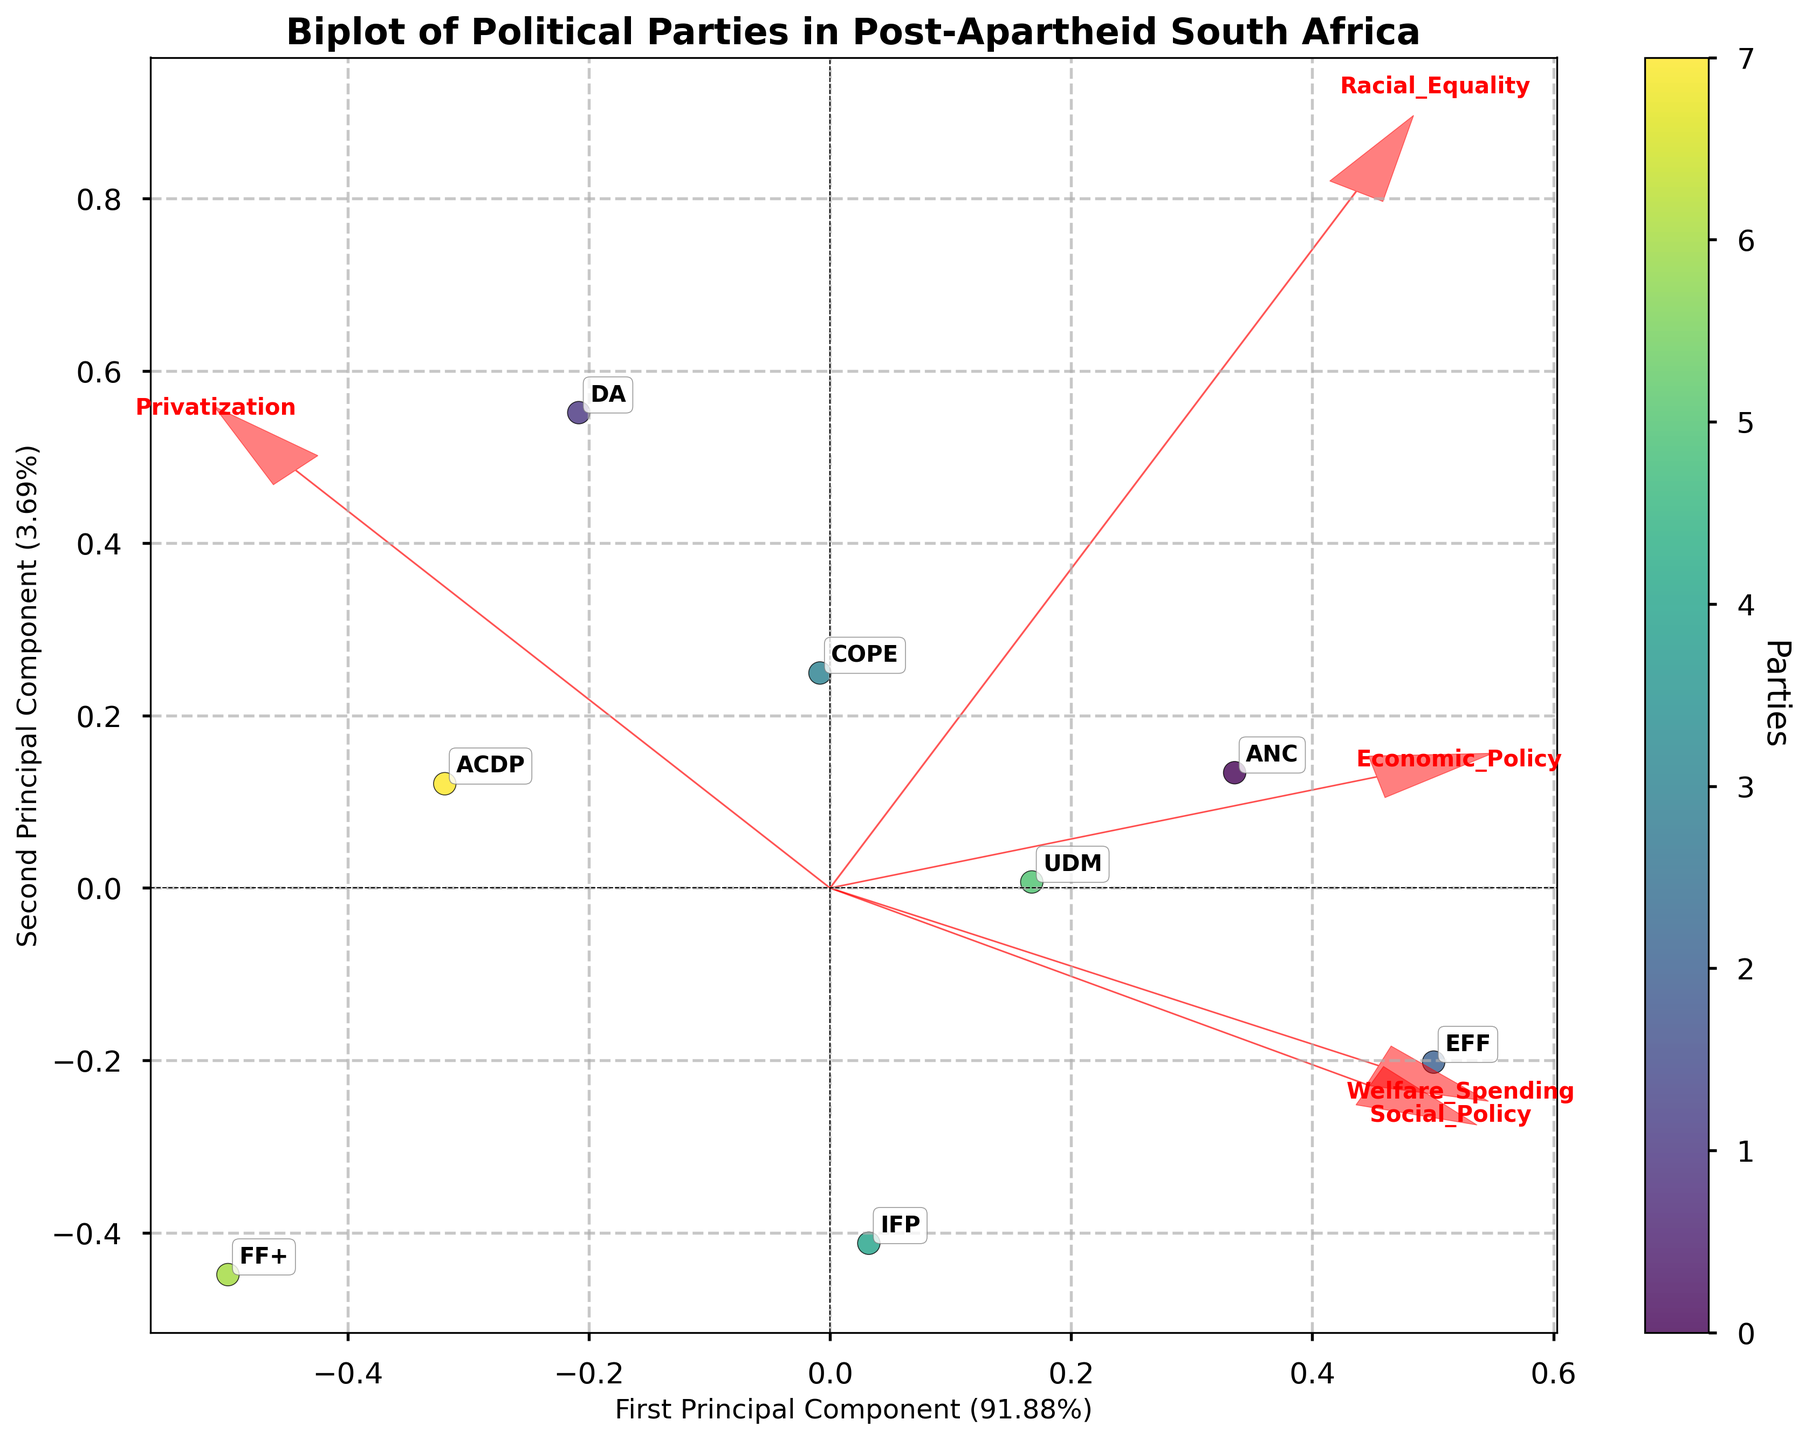What are the titles of the axes? The x-axis represents the "First Principal Component" while the y-axis represents the "Second Principal Component." Both components are derived from the PCA analysis and the variance ratio is also indicated on each axis.
Answer: "First Principal Component" and "Second Principal Component" Which party is closest to the "Racial Equality" vector? To determine which party is closest to the "Racial Equality" vector, observe the direction of the "Racial Equality" arrow in the plot and identify the party that lies closest to this arrow. The EFF is the nearest party to the "Racial Equality" vector.
Answer: EFF Which principal component explains more variance? The axis that indicates the percentage of variance explained allows us to see which principal component has a higher value. The given label percentages signify that the "First Principal Component" explains more variance than the "Second Principal Component."
Answer: First Principal Component How do the ANC and DA parties compare in terms of their stance on "Privatization"? Locate the positions of the ANC and DA on the plot and observe their distances and directions from the "Privatization" vector. The DA is closer to the "Privatization" vector, indicating a more favorable stance towards privatization compared to the ANC.
Answer: DA is more favorable towards privatization than the ANC Which parties are positioned in the quadrant where both principal components have negative values? Identify the quadrant where both the First and Second Principal Components are negative and see which parties lie within this region. The parties in this quadrant are the DA, FF+, and ACDP.
Answer: DA, FF+, ACDP Which party is farthest from the origin? By evaluating the distances of each party from the center of the plot (0,0), the farthest party from the origin can be determined. The EFF is the farthest from the origin among all parties shown.
Answer: EFF What is the general trend for "Welfare Spending" among the parties? The direction of the "Welfare Spending" vector indicates the trend, with parties closer to the arrow supporting higher welfare spending and those farther away opposing it. The EFF, ANC, and UDM are more supportive of welfare spending, whereas DA, FF+, and ACDP are less supportive.
Answer: Support: EFF, ANC, UDM; Oppose: DA, FF+, ACDP Which parties are closest together on the plot? Look for the parties that are visually closest to each other in terms of their coordinates on the biplot. The ANC and UDM are positioned close to each other.
Answer: ANC and UDM How does the ACDP compare to the IFP regarding "Social Policy"? Observe the positions of ACDP and IFP relative to the "Social Policy" vector in the plot. The IFP is closer to the "Social Policy" vector, indicating a more favorable stance on social policies compared to the ACDP.
Answer: IFP is more favorable towards social policies than ACDP 